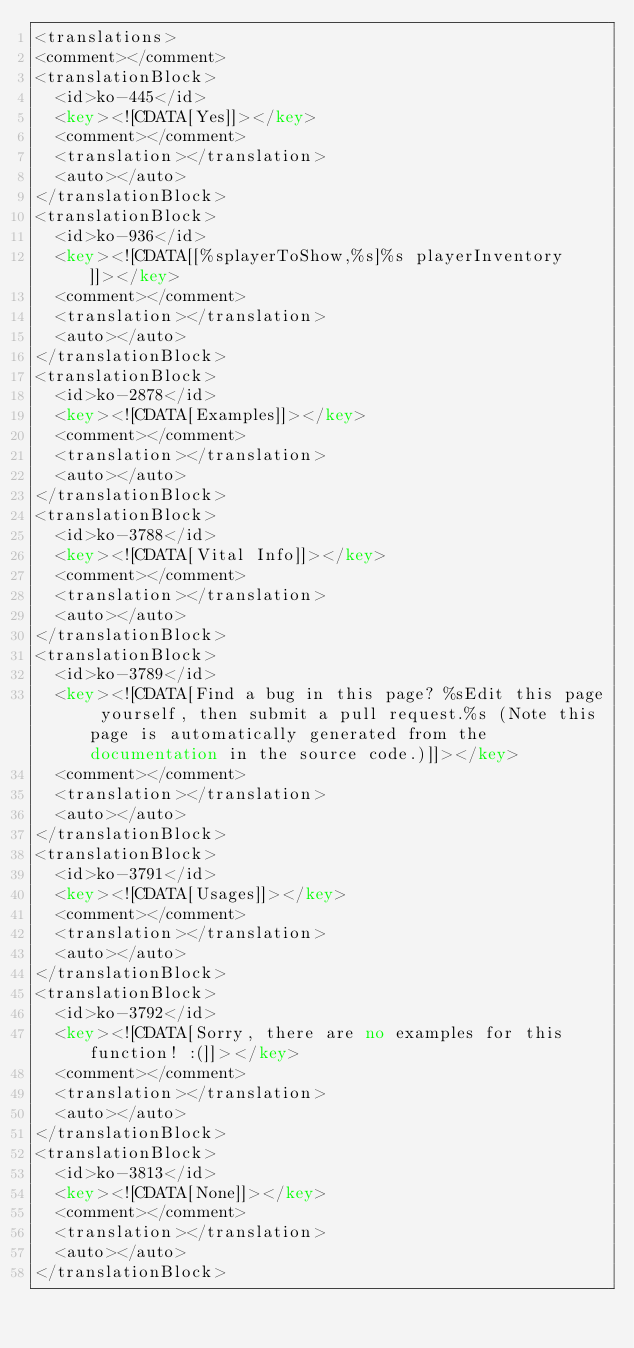<code> <loc_0><loc_0><loc_500><loc_500><_XML_><translations>
<comment></comment>
<translationBlock>
	<id>ko-445</id>
	<key><![CDATA[Yes]]></key>
	<comment></comment>
	<translation></translation>
	<auto></auto>
</translationBlock>
<translationBlock>
	<id>ko-936</id>
	<key><![CDATA[[%splayerToShow,%s]%s playerInventory]]></key>
	<comment></comment>
	<translation></translation>
	<auto></auto>
</translationBlock>
<translationBlock>
	<id>ko-2878</id>
	<key><![CDATA[Examples]]></key>
	<comment></comment>
	<translation></translation>
	<auto></auto>
</translationBlock>
<translationBlock>
	<id>ko-3788</id>
	<key><![CDATA[Vital Info]]></key>
	<comment></comment>
	<translation></translation>
	<auto></auto>
</translationBlock>
<translationBlock>
	<id>ko-3789</id>
	<key><![CDATA[Find a bug in this page? %sEdit this page yourself, then submit a pull request.%s (Note this page is automatically generated from the documentation in the source code.)]]></key>
	<comment></comment>
	<translation></translation>
	<auto></auto>
</translationBlock>
<translationBlock>
	<id>ko-3791</id>
	<key><![CDATA[Usages]]></key>
	<comment></comment>
	<translation></translation>
	<auto></auto>
</translationBlock>
<translationBlock>
	<id>ko-3792</id>
	<key><![CDATA[Sorry, there are no examples for this function! :(]]></key>
	<comment></comment>
	<translation></translation>
	<auto></auto>
</translationBlock>
<translationBlock>
	<id>ko-3813</id>
	<key><![CDATA[None]]></key>
	<comment></comment>
	<translation></translation>
	<auto></auto>
</translationBlock></code> 